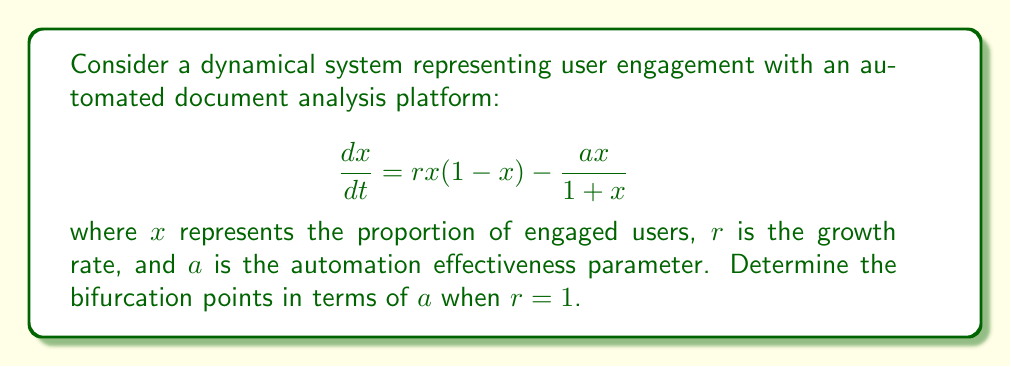Can you solve this math problem? To find the bifurcation points, we need to follow these steps:

1) First, find the equilibrium points by setting $\frac{dx}{dt} = 0$:

   $$rx(1-x) - \frac{ax}{1+x} = 0$$

2) Substitute $r=1$:

   $$x(1-x) - \frac{ax}{1+x} = 0$$

3) Multiply both sides by $(1+x)$:

   $$x(1-x)(1+x) - ax = 0$$

4) Expand:

   $$x(1-x^2) - ax = 0$$
   $$x - x^3 - ax = 0$$

5) Factor out $x$:

   $$x(1 - x^2 - a) = 0$$

6) The solutions are $x=0$ and $x = \pm\sqrt{1-a}$

7) For a bifurcation to occur, we need the non-zero solutions to be real. This happens when:

   $$1-a \geq 0$$
   $$a \leq 1$$

8) The bifurcation occurs when $a = 1$, as this is where the system changes from having three equilibrium points to having only one.

9) To confirm this is a pitchfork bifurcation, we can check the stability of the equilibrium points:

   For $x=0$: $\frac{d}{dx}(\frac{dx}{dt})|_{x=0} = 1 - a$
   
   When $a < 1$, $x=0$ is unstable.
   When $a > 1$, $x=0$ is stable.

   For $x = \pm\sqrt{1-a}$ (when they exist, i.e., $a < 1$):
   $\frac{d}{dx}(\frac{dx}{dt})|_{x=\pm\sqrt{1-a}} = -(1-a)$

   These points are stable when they exist.

Therefore, a pitchfork bifurcation occurs at $a = 1$.
Answer: $a = 1$ 